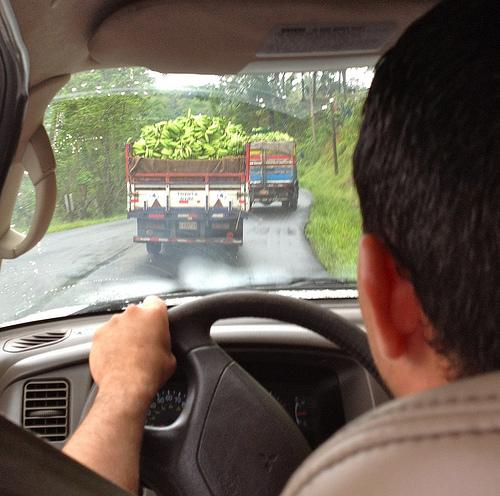What is unique about the bananas in the trucks? The bananas in the trucks are green and unripe. Count the total number of trucks and cars mentioned in the image. There are two trucks and one car mentioned in the image. Identify the color and load of the trucks in the image. There are two trucks in the image - a red and white truck and a red and blue truck, both carrying a load of green bananas. What is the activity happening in the car? A person is driving the car, holding the steering wheel. Describe any common object found in both trucks. Both trucks are hauling loads of green bananas. Explain the condition of the bananas in the image. The bananas in the image are still green, which indicates they are unripe. What are the two main objects in the car's interior? The two main objects in the car's interior are a black steering wheel and a grey air vent. Briefly describe the appearance of the man in the image. The man in the image has brown hair and is driving a car. What is the color of the grass in the image? The grass in the image is green. 